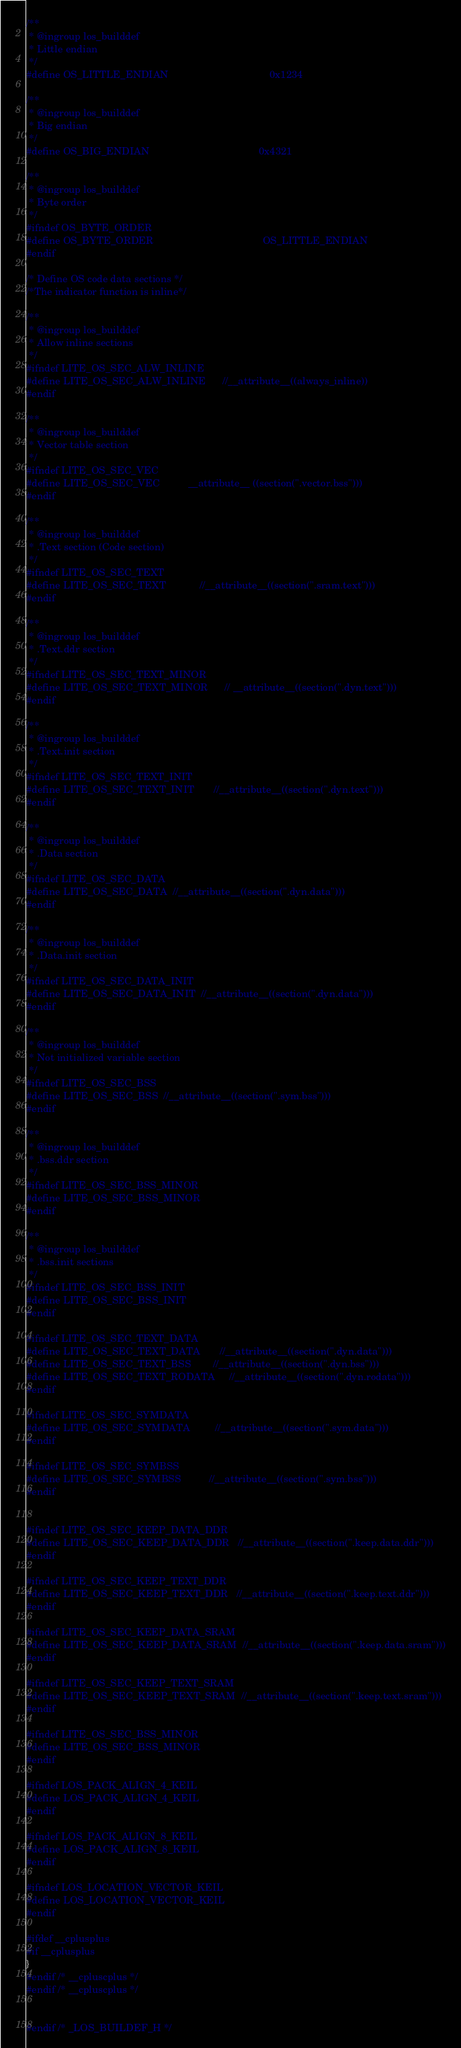<code> <loc_0><loc_0><loc_500><loc_500><_C_>
/**
 * @ingroup los_builddef
 * Little endian
 */
#define OS_LITTLE_ENDIAN                                    0x1234

/**
 * @ingroup los_builddef
 * Big endian
 */
#define OS_BIG_ENDIAN                                       0x4321

/**
 * @ingroup los_builddef
 * Byte order
 */
#ifndef OS_BYTE_ORDER
#define OS_BYTE_ORDER                                       OS_LITTLE_ENDIAN
#endif

/* Define OS code data sections */
/*The indicator function is inline*/

/**
 * @ingroup los_builddef
 * Allow inline sections
 */
#ifndef LITE_OS_SEC_ALW_INLINE
#define LITE_OS_SEC_ALW_INLINE      //__attribute__((always_inline))
#endif

/**
 * @ingroup los_builddef
 * Vector table section
 */
#ifndef LITE_OS_SEC_VEC
#define LITE_OS_SEC_VEC          __attribute__ ((section(".vector.bss")))
#endif

/**
 * @ingroup los_builddef
 * .Text section (Code section)
 */
#ifndef LITE_OS_SEC_TEXT
#define LITE_OS_SEC_TEXT            //__attribute__((section(".sram.text")))
#endif

/**
 * @ingroup los_builddef
 * .Text.ddr section
 */
#ifndef LITE_OS_SEC_TEXT_MINOR
#define LITE_OS_SEC_TEXT_MINOR      // __attribute__((section(".dyn.text")))
#endif

/**
 * @ingroup los_builddef
 * .Text.init section
 */
#ifndef LITE_OS_SEC_TEXT_INIT
#define LITE_OS_SEC_TEXT_INIT       //__attribute__((section(".dyn.text")))
#endif

/**
 * @ingroup los_builddef
 * .Data section
 */
#ifndef LITE_OS_SEC_DATA
#define LITE_OS_SEC_DATA  //__attribute__((section(".dyn.data")))
#endif

/**
 * @ingroup los_builddef
 * .Data.init section
 */
#ifndef LITE_OS_SEC_DATA_INIT
#define LITE_OS_SEC_DATA_INIT  //__attribute__((section(".dyn.data")))
#endif

/**
 * @ingroup los_builddef
 * Not initialized variable section
 */
#ifndef LITE_OS_SEC_BSS
#define LITE_OS_SEC_BSS  //__attribute__((section(".sym.bss")))
#endif

/**
 * @ingroup los_builddef
 * .bss.ddr section
 */
#ifndef LITE_OS_SEC_BSS_MINOR
#define LITE_OS_SEC_BSS_MINOR
#endif

/**
 * @ingroup los_builddef
 * .bss.init sections
 */
#ifndef LITE_OS_SEC_BSS_INIT
#define LITE_OS_SEC_BSS_INIT
#endif

#ifndef LITE_OS_SEC_TEXT_DATA
#define LITE_OS_SEC_TEXT_DATA       //__attribute__((section(".dyn.data")))
#define LITE_OS_SEC_TEXT_BSS        //__attribute__((section(".dyn.bss")))
#define LITE_OS_SEC_TEXT_RODATA     //__attribute__((section(".dyn.rodata")))
#endif

#ifndef LITE_OS_SEC_SYMDATA
#define LITE_OS_SEC_SYMDATA         //__attribute__((section(".sym.data")))
#endif

#ifndef LITE_OS_SEC_SYMBSS
#define LITE_OS_SEC_SYMBSS          //__attribute__((section(".sym.bss")))
#endif


#ifndef LITE_OS_SEC_KEEP_DATA_DDR
#define LITE_OS_SEC_KEEP_DATA_DDR   //__attribute__((section(".keep.data.ddr")))
#endif

#ifndef LITE_OS_SEC_KEEP_TEXT_DDR
#define LITE_OS_SEC_KEEP_TEXT_DDR   //__attribute__((section(".keep.text.ddr")))
#endif

#ifndef LITE_OS_SEC_KEEP_DATA_SRAM
#define LITE_OS_SEC_KEEP_DATA_SRAM  //__attribute__((section(".keep.data.sram")))
#endif

#ifndef LITE_OS_SEC_KEEP_TEXT_SRAM
#define LITE_OS_SEC_KEEP_TEXT_SRAM  //__attribute__((section(".keep.text.sram")))
#endif

#ifndef LITE_OS_SEC_BSS_MINOR
#define LITE_OS_SEC_BSS_MINOR
#endif

#ifndef LOS_PACK_ALIGN_4_KEIL
#define LOS_PACK_ALIGN_4_KEIL
#endif

#ifndef LOS_PACK_ALIGN_8_KEIL
#define LOS_PACK_ALIGN_8_KEIL
#endif

#ifndef LOS_LOCATION_VECTOR_KEIL
#define LOS_LOCATION_VECTOR_KEIL
#endif

#ifdef __cplusplus
#if __cplusplus
}
#endif /* __cpluscplus */
#endif /* __cpluscplus */


#endif /* _LOS_BUILDEF_H */
</code> 